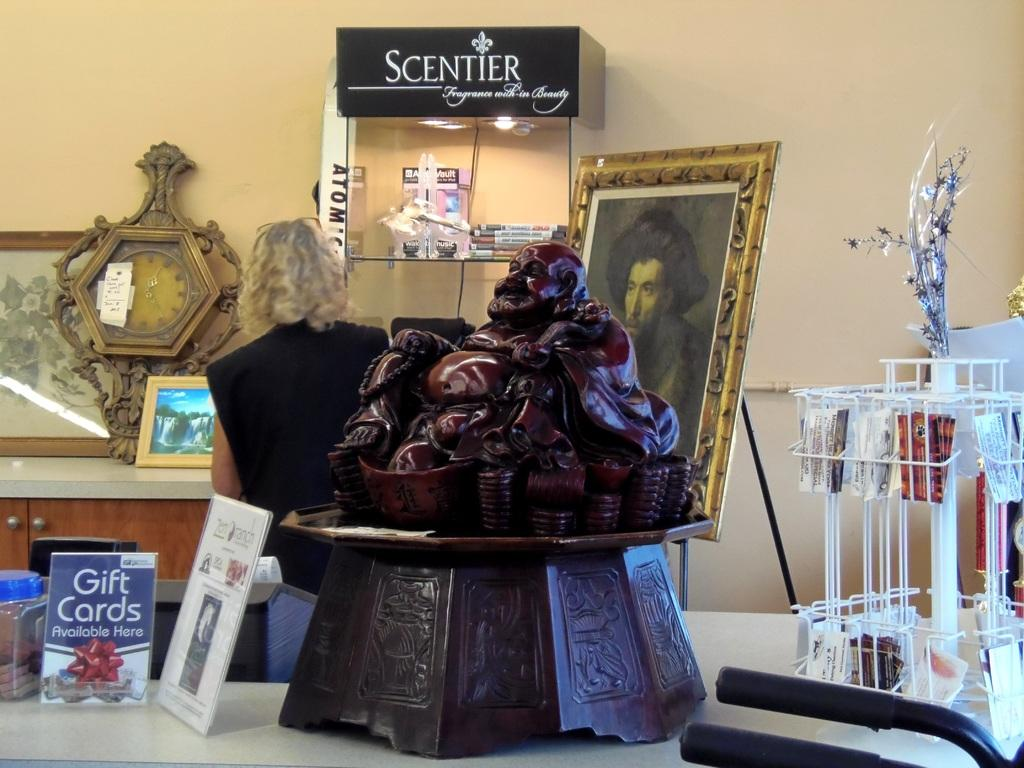What type of furniture is present in the image? There is a table in the image. What can be seen hanging on the wall in the background? There are photo frames in the image. What is on top of the table? There are objects on the table. What is visible behind the table in the image? There is a wall in the background of the image. What type of sweater is the faucet wearing in the image? There is no faucet or sweater present in the image. 